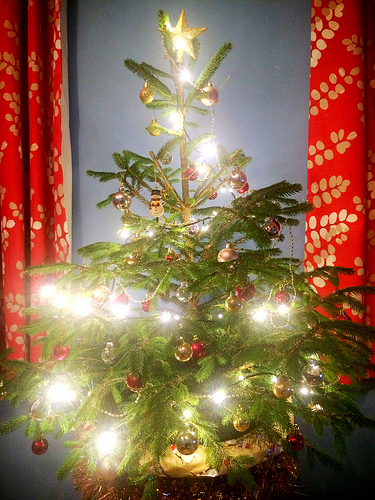<image>
Is there a christmas tree in front of the curtains? Yes. The christmas tree is positioned in front of the curtains, appearing closer to the camera viewpoint. 